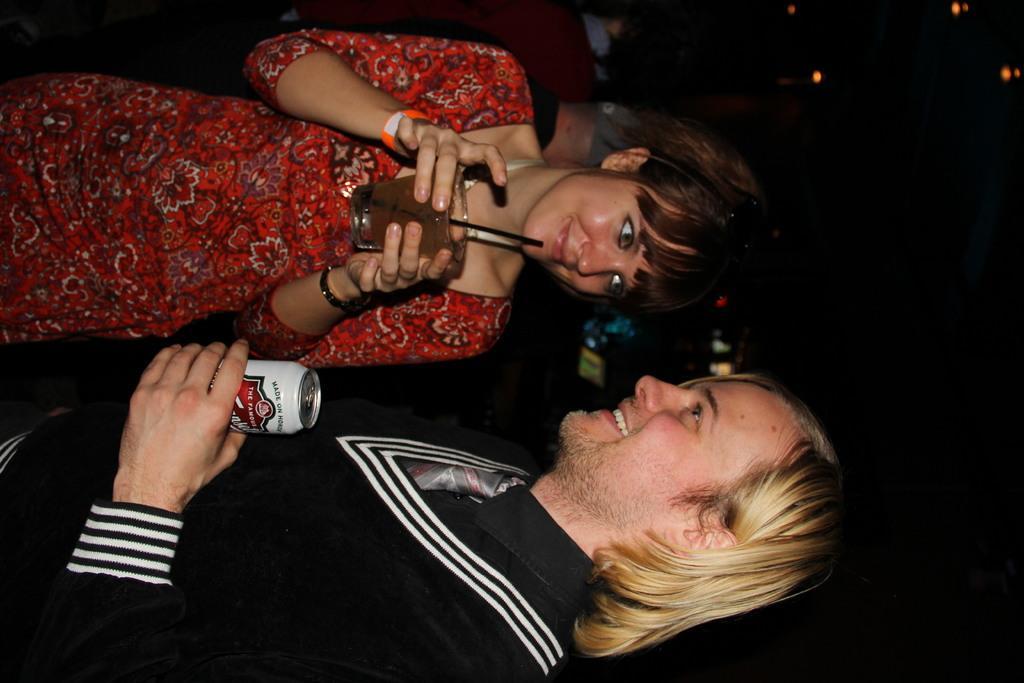In one or two sentences, can you explain what this image depicts? As we can see in the image there are two people. The man over here is wearing a black color dress and holding a tin. The woman is wearing red color dress and holding glass. In the background there are few people and the background is blurred. 